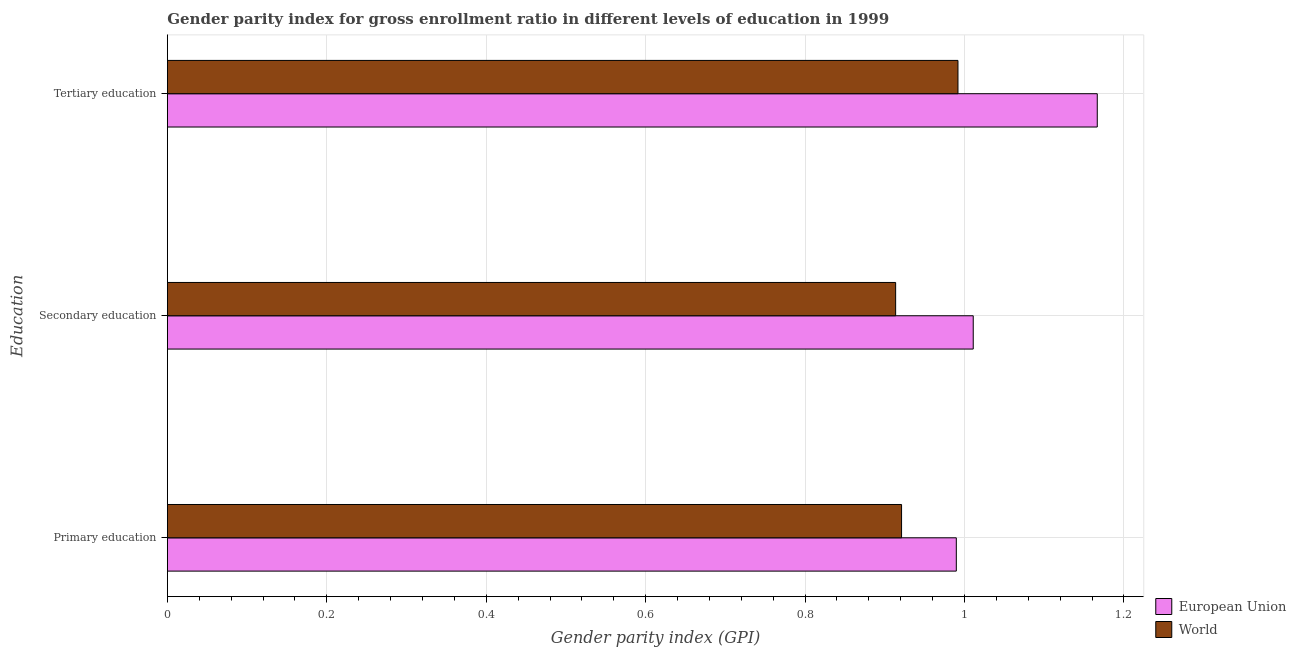How many groups of bars are there?
Keep it short and to the point. 3. Are the number of bars per tick equal to the number of legend labels?
Make the answer very short. Yes. How many bars are there on the 2nd tick from the top?
Ensure brevity in your answer.  2. What is the label of the 1st group of bars from the top?
Offer a terse response. Tertiary education. What is the gender parity index in secondary education in World?
Your response must be concise. 0.91. Across all countries, what is the maximum gender parity index in primary education?
Provide a short and direct response. 0.99. Across all countries, what is the minimum gender parity index in secondary education?
Offer a very short reply. 0.91. In which country was the gender parity index in tertiary education minimum?
Keep it short and to the point. World. What is the total gender parity index in tertiary education in the graph?
Make the answer very short. 2.16. What is the difference between the gender parity index in tertiary education in World and that in European Union?
Keep it short and to the point. -0.17. What is the difference between the gender parity index in tertiary education in World and the gender parity index in secondary education in European Union?
Your response must be concise. -0.02. What is the average gender parity index in primary education per country?
Offer a terse response. 0.96. What is the difference between the gender parity index in primary education and gender parity index in tertiary education in World?
Offer a terse response. -0.07. What is the ratio of the gender parity index in tertiary education in World to that in European Union?
Your answer should be very brief. 0.85. Is the gender parity index in secondary education in World less than that in European Union?
Make the answer very short. Yes. Is the difference between the gender parity index in tertiary education in European Union and World greater than the difference between the gender parity index in primary education in European Union and World?
Keep it short and to the point. Yes. What is the difference between the highest and the second highest gender parity index in tertiary education?
Keep it short and to the point. 0.17. What is the difference between the highest and the lowest gender parity index in tertiary education?
Your answer should be very brief. 0.17. In how many countries, is the gender parity index in primary education greater than the average gender parity index in primary education taken over all countries?
Your answer should be very brief. 1. What does the 1st bar from the bottom in Primary education represents?
Your response must be concise. European Union. How many bars are there?
Provide a succinct answer. 6. Does the graph contain grids?
Your response must be concise. Yes. Where does the legend appear in the graph?
Your answer should be very brief. Bottom right. How many legend labels are there?
Make the answer very short. 2. How are the legend labels stacked?
Keep it short and to the point. Vertical. What is the title of the graph?
Provide a succinct answer. Gender parity index for gross enrollment ratio in different levels of education in 1999. What is the label or title of the X-axis?
Your response must be concise. Gender parity index (GPI). What is the label or title of the Y-axis?
Provide a short and direct response. Education. What is the Gender parity index (GPI) of European Union in Primary education?
Offer a very short reply. 0.99. What is the Gender parity index (GPI) of World in Primary education?
Your response must be concise. 0.92. What is the Gender parity index (GPI) in European Union in Secondary education?
Offer a very short reply. 1.01. What is the Gender parity index (GPI) of World in Secondary education?
Give a very brief answer. 0.91. What is the Gender parity index (GPI) in European Union in Tertiary education?
Offer a very short reply. 1.17. What is the Gender parity index (GPI) of World in Tertiary education?
Offer a terse response. 0.99. Across all Education, what is the maximum Gender parity index (GPI) in European Union?
Your response must be concise. 1.17. Across all Education, what is the maximum Gender parity index (GPI) of World?
Offer a terse response. 0.99. Across all Education, what is the minimum Gender parity index (GPI) in European Union?
Your response must be concise. 0.99. Across all Education, what is the minimum Gender parity index (GPI) in World?
Ensure brevity in your answer.  0.91. What is the total Gender parity index (GPI) in European Union in the graph?
Make the answer very short. 3.17. What is the total Gender parity index (GPI) of World in the graph?
Your response must be concise. 2.83. What is the difference between the Gender parity index (GPI) of European Union in Primary education and that in Secondary education?
Keep it short and to the point. -0.02. What is the difference between the Gender parity index (GPI) in World in Primary education and that in Secondary education?
Provide a succinct answer. 0.01. What is the difference between the Gender parity index (GPI) in European Union in Primary education and that in Tertiary education?
Ensure brevity in your answer.  -0.18. What is the difference between the Gender parity index (GPI) of World in Primary education and that in Tertiary education?
Your answer should be very brief. -0.07. What is the difference between the Gender parity index (GPI) of European Union in Secondary education and that in Tertiary education?
Your answer should be compact. -0.16. What is the difference between the Gender parity index (GPI) of World in Secondary education and that in Tertiary education?
Your response must be concise. -0.08. What is the difference between the Gender parity index (GPI) in European Union in Primary education and the Gender parity index (GPI) in World in Secondary education?
Keep it short and to the point. 0.08. What is the difference between the Gender parity index (GPI) in European Union in Primary education and the Gender parity index (GPI) in World in Tertiary education?
Your answer should be compact. -0. What is the difference between the Gender parity index (GPI) of European Union in Secondary education and the Gender parity index (GPI) of World in Tertiary education?
Your answer should be very brief. 0.02. What is the average Gender parity index (GPI) of European Union per Education?
Ensure brevity in your answer.  1.06. What is the average Gender parity index (GPI) in World per Education?
Provide a short and direct response. 0.94. What is the difference between the Gender parity index (GPI) of European Union and Gender parity index (GPI) of World in Primary education?
Ensure brevity in your answer.  0.07. What is the difference between the Gender parity index (GPI) of European Union and Gender parity index (GPI) of World in Secondary education?
Keep it short and to the point. 0.1. What is the difference between the Gender parity index (GPI) in European Union and Gender parity index (GPI) in World in Tertiary education?
Offer a very short reply. 0.17. What is the ratio of the Gender parity index (GPI) of European Union in Primary education to that in Tertiary education?
Your answer should be very brief. 0.85. What is the ratio of the Gender parity index (GPI) of World in Primary education to that in Tertiary education?
Make the answer very short. 0.93. What is the ratio of the Gender parity index (GPI) in European Union in Secondary education to that in Tertiary education?
Offer a very short reply. 0.87. What is the ratio of the Gender parity index (GPI) in World in Secondary education to that in Tertiary education?
Offer a terse response. 0.92. What is the difference between the highest and the second highest Gender parity index (GPI) in European Union?
Give a very brief answer. 0.16. What is the difference between the highest and the second highest Gender parity index (GPI) in World?
Your answer should be very brief. 0.07. What is the difference between the highest and the lowest Gender parity index (GPI) in European Union?
Your answer should be compact. 0.18. What is the difference between the highest and the lowest Gender parity index (GPI) of World?
Make the answer very short. 0.08. 